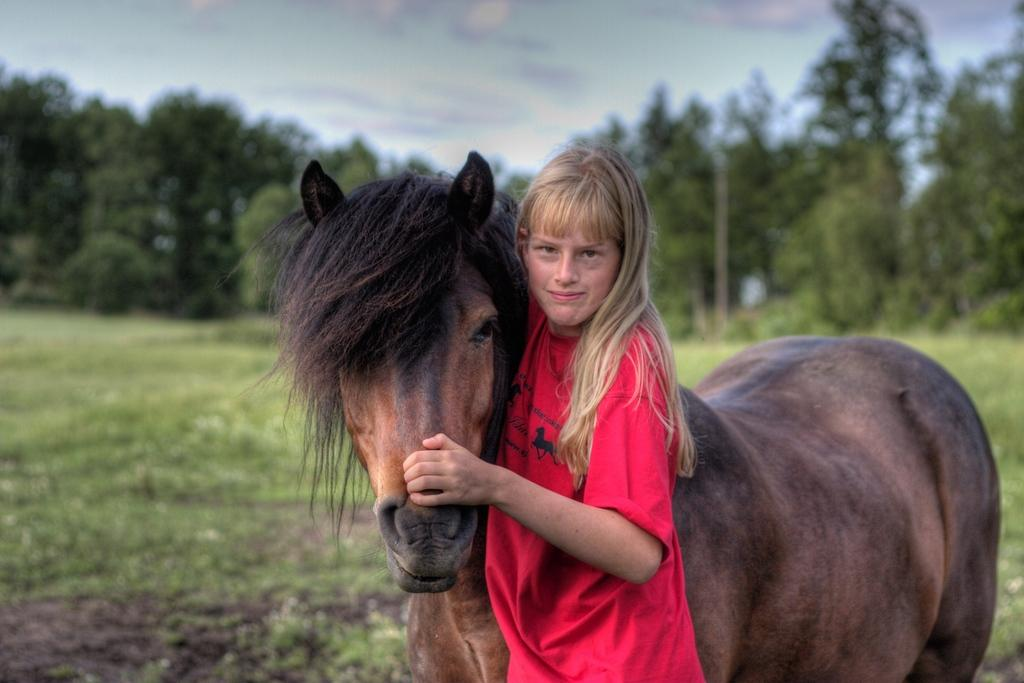What is the main subject of the image? There is a person in the image. What is the person wearing? The person is wearing a red t-shirt. What is the person holding in the image? The person is holding a horse. What type of terrain is visible in the image? There is grass visible in the image. What can be seen in the background of the image? There are many trees in the background of the image. Can you see any wings on the person in the image? No, there are no wings visible on the person in the image. What type of doll is sitting on the ship in the image? There is no doll or ship present in the image. 